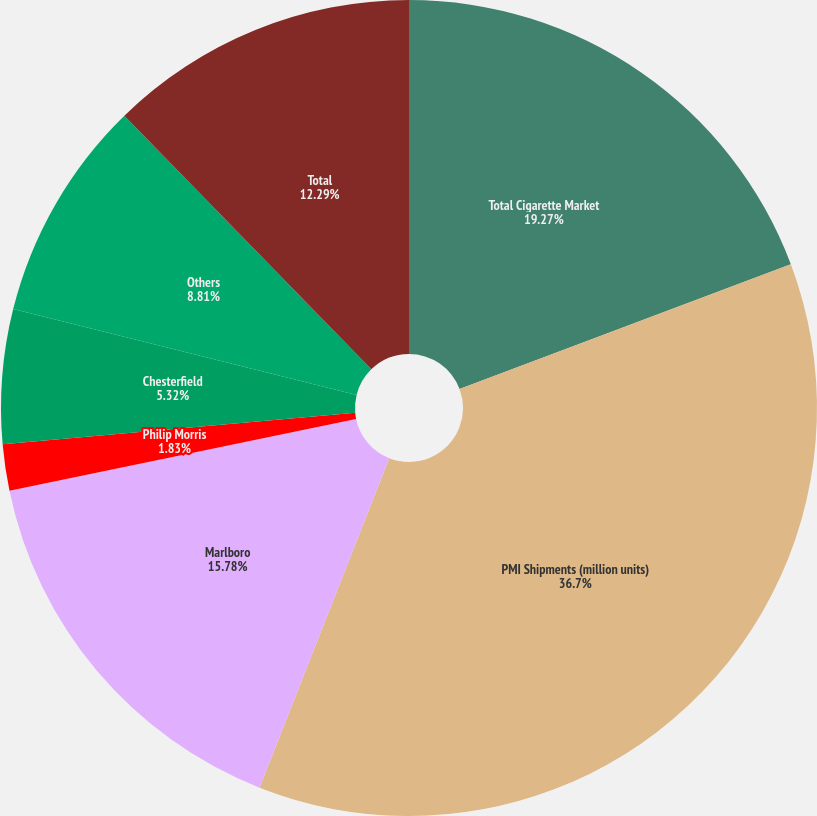<chart> <loc_0><loc_0><loc_500><loc_500><pie_chart><fcel>Total Cigarette Market<fcel>PMI Shipments (million units)<fcel>Marlboro<fcel>Philip Morris<fcel>Chesterfield<fcel>Others<fcel>Total<nl><fcel>19.27%<fcel>36.7%<fcel>15.78%<fcel>1.83%<fcel>5.32%<fcel>8.81%<fcel>12.29%<nl></chart> 